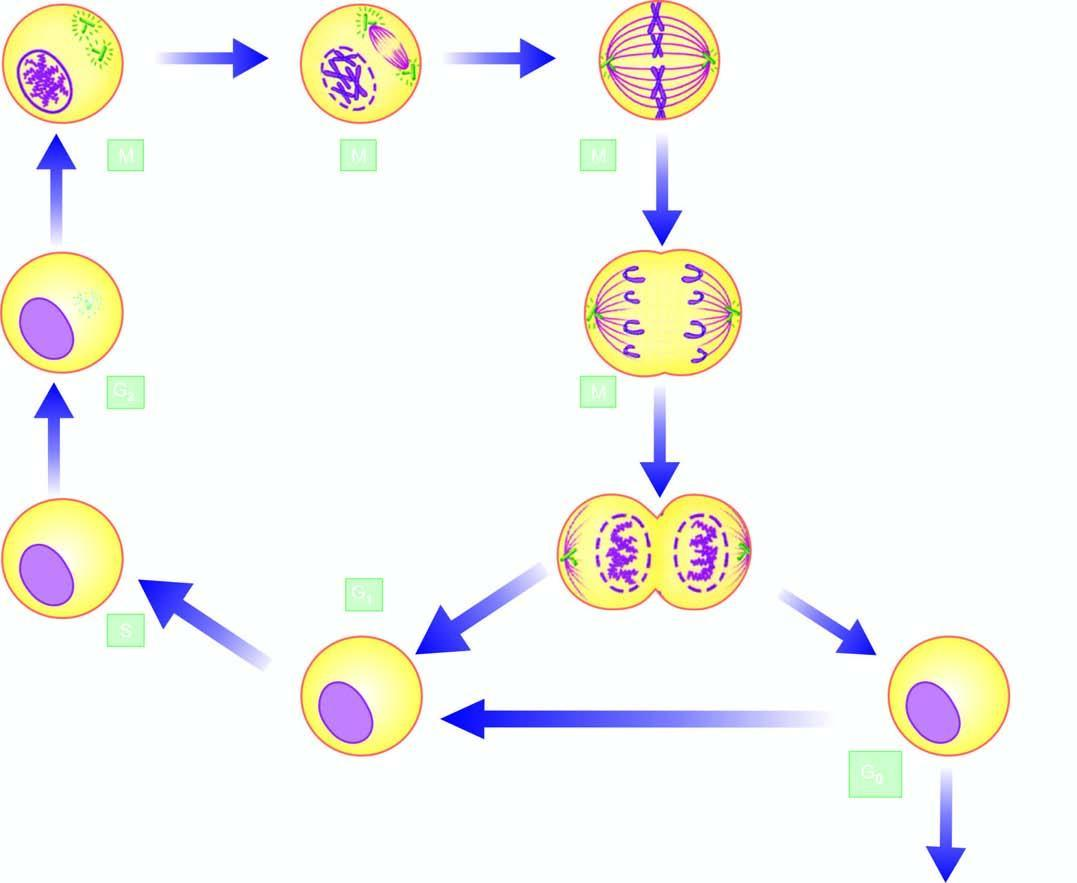re m phase the g1, s and g2 phase while m phase is accomplished in 4 sequential stages: prophase, metaphase, anaphase, and telophase?
Answer the question using a single word or phrase. No 